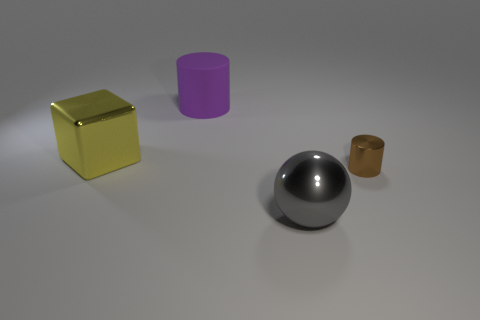Add 4 metallic objects. How many objects exist? 8 Subtract all balls. How many objects are left? 3 Subtract 0 blue cylinders. How many objects are left? 4 Subtract all big purple things. Subtract all metal cylinders. How many objects are left? 2 Add 4 gray metal things. How many gray metal things are left? 5 Add 4 gray balls. How many gray balls exist? 5 